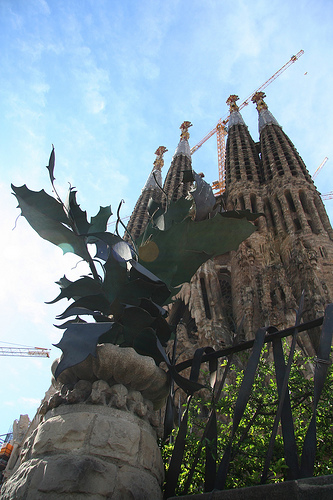<image>
Is there a church in the crane? No. The church is not contained within the crane. These objects have a different spatial relationship. Is there a structure in front of the gate? No. The structure is not in front of the gate. The spatial positioning shows a different relationship between these objects. 